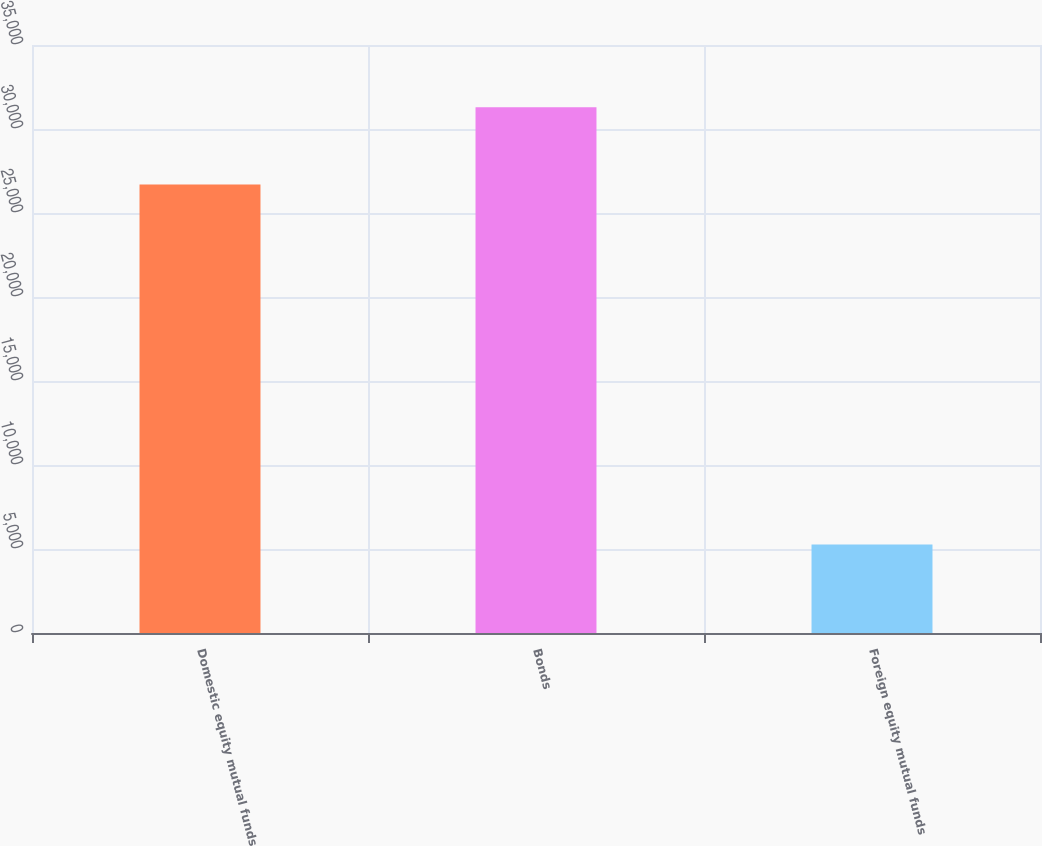Convert chart to OTSL. <chart><loc_0><loc_0><loc_500><loc_500><bar_chart><fcel>Domestic equity mutual funds<fcel>Bonds<fcel>Foreign equity mutual funds<nl><fcel>26692<fcel>31296<fcel>5261<nl></chart> 